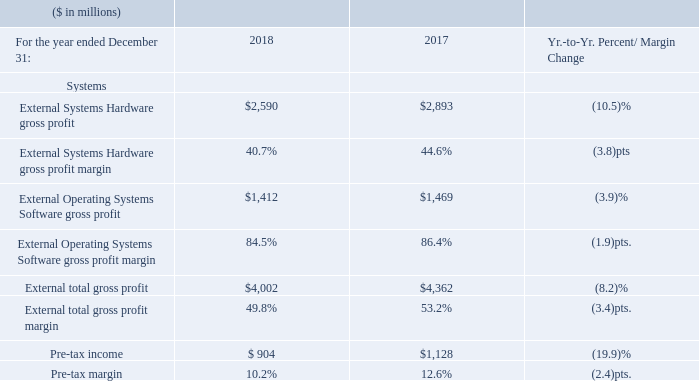The Systems gross profit margin decrease year to year was driven by the mix away from IBM Z and margin declines in Power Systems and Storage Systems.
The pre-tax income decline was driven by the strong performance in IBM Z in the prior year and the continued investment in innovation across the Systems portfolio.
What led to decrease in Systems gross profit margin? The systems gross profit margin decrease year to year was driven by the mix away from ibm z and margin declines in power systems and storage systems. What led to decrease in pre-tax income? The pre-tax income decline was driven by the strong performance in ibm z in the prior year and the continued investment in innovation across the systems portfolio. Did the Systems gross profit margin increase or decrease year to year? The systems gross profit margin decrease year to year. What is the average of External Systems Hardware gross profit?
Answer scale should be: million. (2,590+2,893) / 2
Answer: 2741.5. What is the increase/ (decrease) in External Systems Hardware gross profit from 2017 to 2018
Answer scale should be: million. 2,590-2,893
Answer: -303. What is the increase/ (decrease) in Pre-tax margin from 2017 to 2018
Answer scale should be: percent. 10.2-12.6 
Answer: -2.4. 